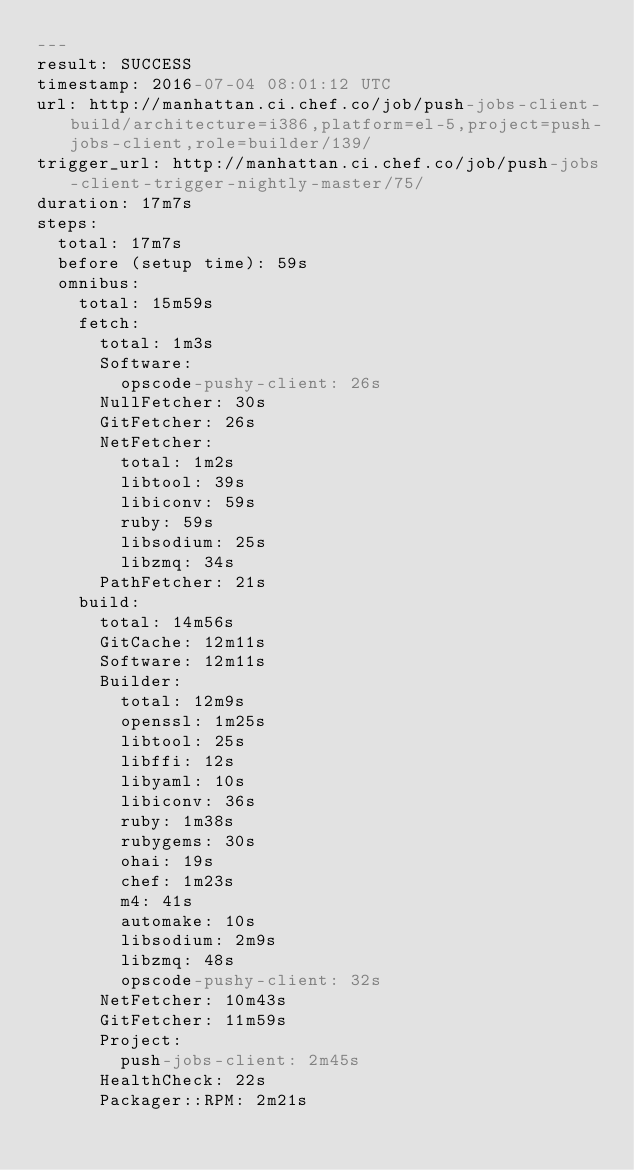<code> <loc_0><loc_0><loc_500><loc_500><_YAML_>---
result: SUCCESS
timestamp: 2016-07-04 08:01:12 UTC
url: http://manhattan.ci.chef.co/job/push-jobs-client-build/architecture=i386,platform=el-5,project=push-jobs-client,role=builder/139/
trigger_url: http://manhattan.ci.chef.co/job/push-jobs-client-trigger-nightly-master/75/
duration: 17m7s
steps:
  total: 17m7s
  before (setup time): 59s
  omnibus:
    total: 15m59s
    fetch:
      total: 1m3s
      Software:
        opscode-pushy-client: 26s
      NullFetcher: 30s
      GitFetcher: 26s
      NetFetcher:
        total: 1m2s
        libtool: 39s
        libiconv: 59s
        ruby: 59s
        libsodium: 25s
        libzmq: 34s
      PathFetcher: 21s
    build:
      total: 14m56s
      GitCache: 12m11s
      Software: 12m11s
      Builder:
        total: 12m9s
        openssl: 1m25s
        libtool: 25s
        libffi: 12s
        libyaml: 10s
        libiconv: 36s
        ruby: 1m38s
        rubygems: 30s
        ohai: 19s
        chef: 1m23s
        m4: 41s
        automake: 10s
        libsodium: 2m9s
        libzmq: 48s
        opscode-pushy-client: 32s
      NetFetcher: 10m43s
      GitFetcher: 11m59s
      Project:
        push-jobs-client: 2m45s
      HealthCheck: 22s
      Packager::RPM: 2m21s
</code> 